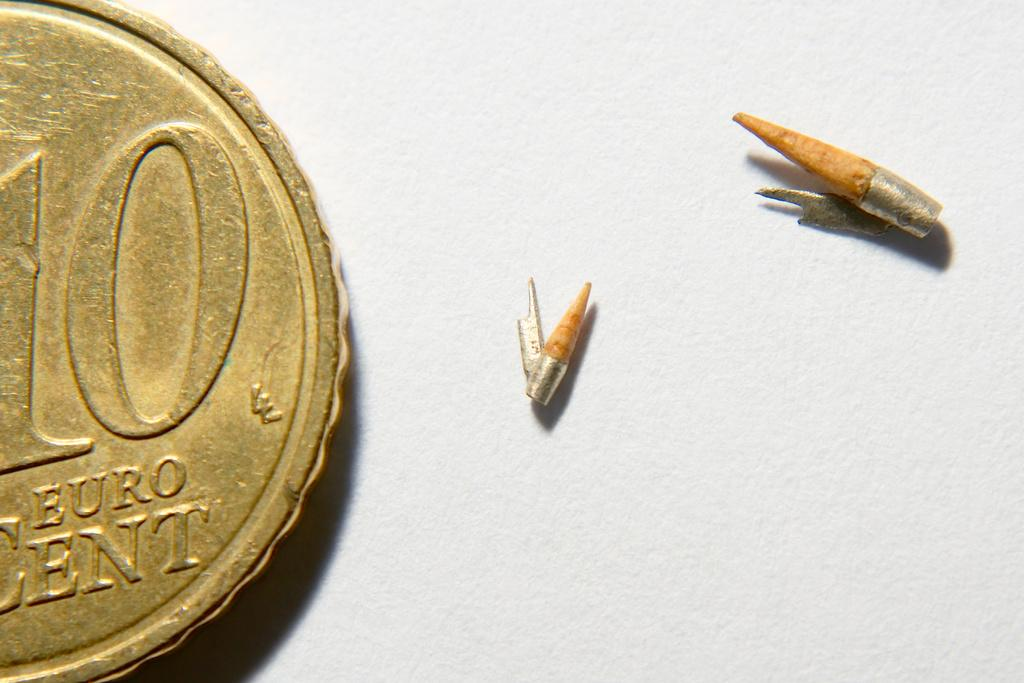<image>
Write a terse but informative summary of the picture. A 10 cent Euro coin with bits of broken pencil. 